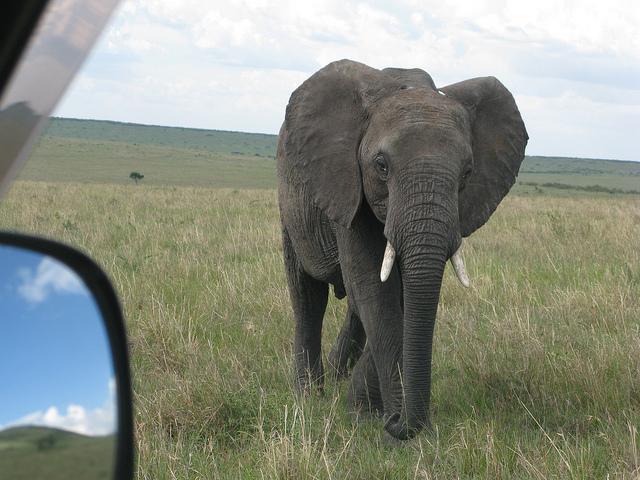How many tusk does this elephant have?
Give a very brief answer. 2. 